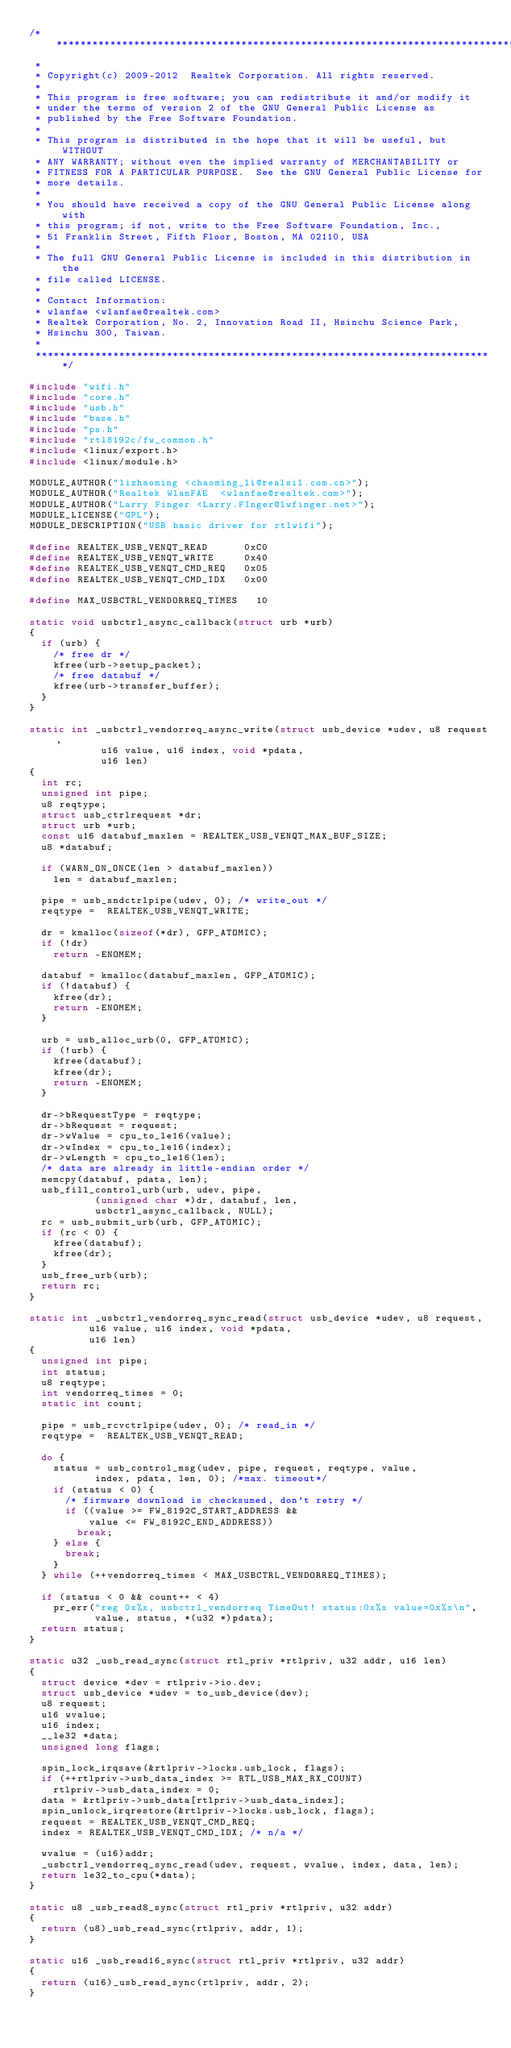Convert code to text. <code><loc_0><loc_0><loc_500><loc_500><_C_>/******************************************************************************
 *
 * Copyright(c) 2009-2012  Realtek Corporation. All rights reserved.
 *
 * This program is free software; you can redistribute it and/or modify it
 * under the terms of version 2 of the GNU General Public License as
 * published by the Free Software Foundation.
 *
 * This program is distributed in the hope that it will be useful, but WITHOUT
 * ANY WARRANTY; without even the implied warranty of MERCHANTABILITY or
 * FITNESS FOR A PARTICULAR PURPOSE.  See the GNU General Public License for
 * more details.
 *
 * You should have received a copy of the GNU General Public License along with
 * this program; if not, write to the Free Software Foundation, Inc.,
 * 51 Franklin Street, Fifth Floor, Boston, MA 02110, USA
 *
 * The full GNU General Public License is included in this distribution in the
 * file called LICENSE.
 *
 * Contact Information:
 * wlanfae <wlanfae@realtek.com>
 * Realtek Corporation, No. 2, Innovation Road II, Hsinchu Science Park,
 * Hsinchu 300, Taiwan.
 *
 *****************************************************************************/

#include "wifi.h"
#include "core.h"
#include "usb.h"
#include "base.h"
#include "ps.h"
#include "rtl8192c/fw_common.h"
#include <linux/export.h>
#include <linux/module.h>

MODULE_AUTHOR("lizhaoming	<chaoming_li@realsil.com.cn>");
MODULE_AUTHOR("Realtek WlanFAE	<wlanfae@realtek.com>");
MODULE_AUTHOR("Larry Finger	<Larry.FInger@lwfinger.net>");
MODULE_LICENSE("GPL");
MODULE_DESCRIPTION("USB basic driver for rtlwifi");

#define	REALTEK_USB_VENQT_READ			0xC0
#define	REALTEK_USB_VENQT_WRITE			0x40
#define REALTEK_USB_VENQT_CMD_REQ		0x05
#define	REALTEK_USB_VENQT_CMD_IDX		0x00

#define MAX_USBCTRL_VENDORREQ_TIMES		10

static void usbctrl_async_callback(struct urb *urb)
{
	if (urb) {
		/* free dr */
		kfree(urb->setup_packet);
		/* free databuf */
		kfree(urb->transfer_buffer);
	}
}

static int _usbctrl_vendorreq_async_write(struct usb_device *udev, u8 request,
					  u16 value, u16 index, void *pdata,
					  u16 len)
{
	int rc;
	unsigned int pipe;
	u8 reqtype;
	struct usb_ctrlrequest *dr;
	struct urb *urb;
	const u16 databuf_maxlen = REALTEK_USB_VENQT_MAX_BUF_SIZE;
	u8 *databuf;

	if (WARN_ON_ONCE(len > databuf_maxlen))
		len = databuf_maxlen;

	pipe = usb_sndctrlpipe(udev, 0); /* write_out */
	reqtype =  REALTEK_USB_VENQT_WRITE;

	dr = kmalloc(sizeof(*dr), GFP_ATOMIC);
	if (!dr)
		return -ENOMEM;

	databuf = kmalloc(databuf_maxlen, GFP_ATOMIC);
	if (!databuf) {
		kfree(dr);
		return -ENOMEM;
	}

	urb = usb_alloc_urb(0, GFP_ATOMIC);
	if (!urb) {
		kfree(databuf);
		kfree(dr);
		return -ENOMEM;
	}

	dr->bRequestType = reqtype;
	dr->bRequest = request;
	dr->wValue = cpu_to_le16(value);
	dr->wIndex = cpu_to_le16(index);
	dr->wLength = cpu_to_le16(len);
	/* data are already in little-endian order */
	memcpy(databuf, pdata, len);
	usb_fill_control_urb(urb, udev, pipe,
			     (unsigned char *)dr, databuf, len,
			     usbctrl_async_callback, NULL);
	rc = usb_submit_urb(urb, GFP_ATOMIC);
	if (rc < 0) {
		kfree(databuf);
		kfree(dr);
	}
	usb_free_urb(urb);
	return rc;
}

static int _usbctrl_vendorreq_sync_read(struct usb_device *udev, u8 request,
					u16 value, u16 index, void *pdata,
					u16 len)
{
	unsigned int pipe;
	int status;
	u8 reqtype;
	int vendorreq_times = 0;
	static int count;

	pipe = usb_rcvctrlpipe(udev, 0); /* read_in */
	reqtype =  REALTEK_USB_VENQT_READ;

	do {
		status = usb_control_msg(udev, pipe, request, reqtype, value,
					 index, pdata, len, 0); /*max. timeout*/
		if (status < 0) {
			/* firmware download is checksumed, don't retry */
			if ((value >= FW_8192C_START_ADDRESS &&
			    value <= FW_8192C_END_ADDRESS))
				break;
		} else {
			break;
		}
	} while (++vendorreq_times < MAX_USBCTRL_VENDORREQ_TIMES);

	if (status < 0 && count++ < 4)
		pr_err("reg 0x%x, usbctrl_vendorreq TimeOut! status:0x%x value=0x%x\n",
		       value, status, *(u32 *)pdata);
	return status;
}

static u32 _usb_read_sync(struct rtl_priv *rtlpriv, u32 addr, u16 len)
{
	struct device *dev = rtlpriv->io.dev;
	struct usb_device *udev = to_usb_device(dev);
	u8 request;
	u16 wvalue;
	u16 index;
	__le32 *data;
	unsigned long flags;

	spin_lock_irqsave(&rtlpriv->locks.usb_lock, flags);
	if (++rtlpriv->usb_data_index >= RTL_USB_MAX_RX_COUNT)
		rtlpriv->usb_data_index = 0;
	data = &rtlpriv->usb_data[rtlpriv->usb_data_index];
	spin_unlock_irqrestore(&rtlpriv->locks.usb_lock, flags);
	request = REALTEK_USB_VENQT_CMD_REQ;
	index = REALTEK_USB_VENQT_CMD_IDX; /* n/a */

	wvalue = (u16)addr;
	_usbctrl_vendorreq_sync_read(udev, request, wvalue, index, data, len);
	return le32_to_cpu(*data);
}

static u8 _usb_read8_sync(struct rtl_priv *rtlpriv, u32 addr)
{
	return (u8)_usb_read_sync(rtlpriv, addr, 1);
}

static u16 _usb_read16_sync(struct rtl_priv *rtlpriv, u32 addr)
{
	return (u16)_usb_read_sync(rtlpriv, addr, 2);
}
</code> 